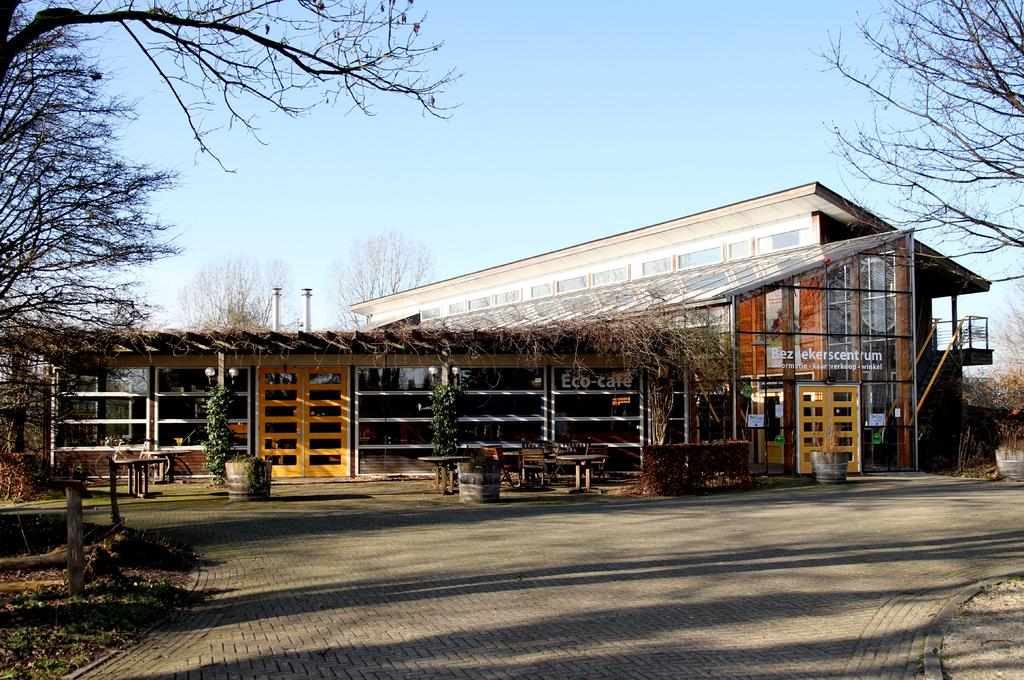What type of structures can be seen in the image? There are buildings in the image. What natural elements are present in the image? There are trees and plants in the image. What type of furniture is visible in the image? There are tables in the image. What part of the natural environment is visible in the image? The sky is visible in the image. How many minutes does it take for the volleyball to be transported in the image? There is no volleyball present in the image, so it is not possible to determine how long it would take to transport one. 